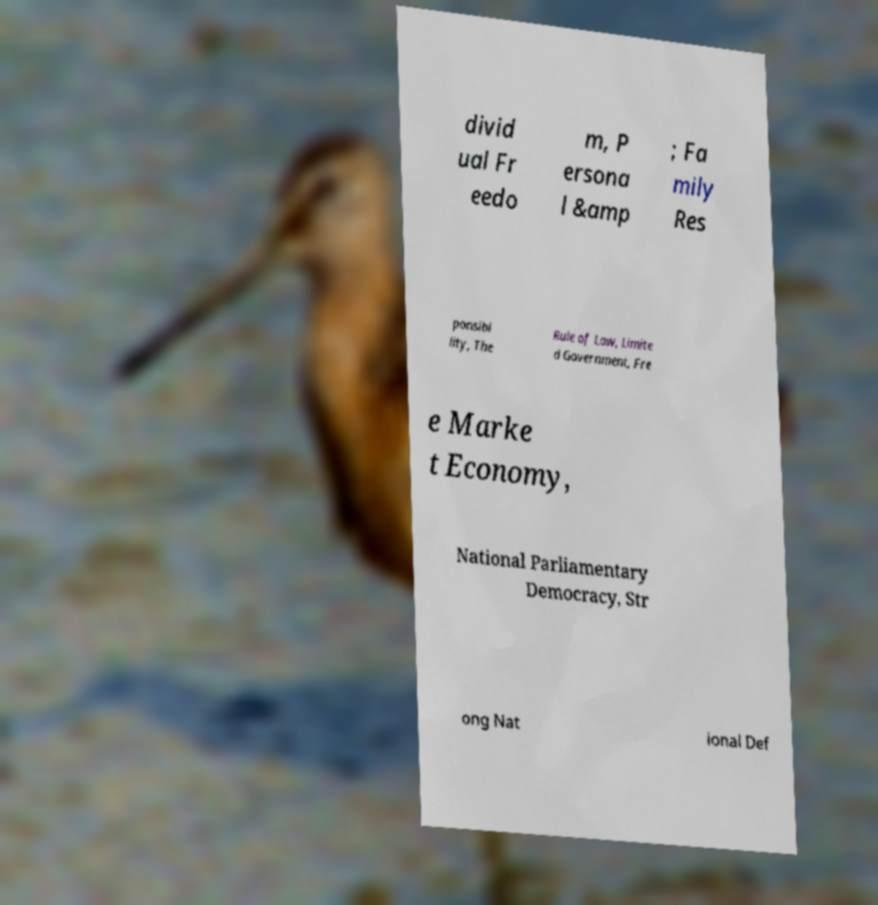There's text embedded in this image that I need extracted. Can you transcribe it verbatim? divid ual Fr eedo m, P ersona l &amp ; Fa mily Res ponsibi lity, The Rule of Law, Limite d Government, Fre e Marke t Economy, National Parliamentary Democracy, Str ong Nat ional Def 